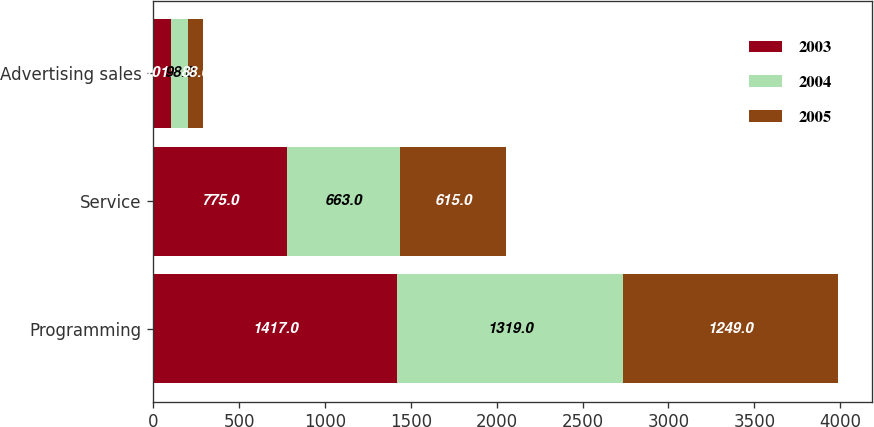<chart> <loc_0><loc_0><loc_500><loc_500><stacked_bar_chart><ecel><fcel>Programming<fcel>Service<fcel>Advertising sales<nl><fcel>2003<fcel>1417<fcel>775<fcel>101<nl><fcel>2004<fcel>1319<fcel>663<fcel>98<nl><fcel>2005<fcel>1249<fcel>615<fcel>88<nl></chart> 